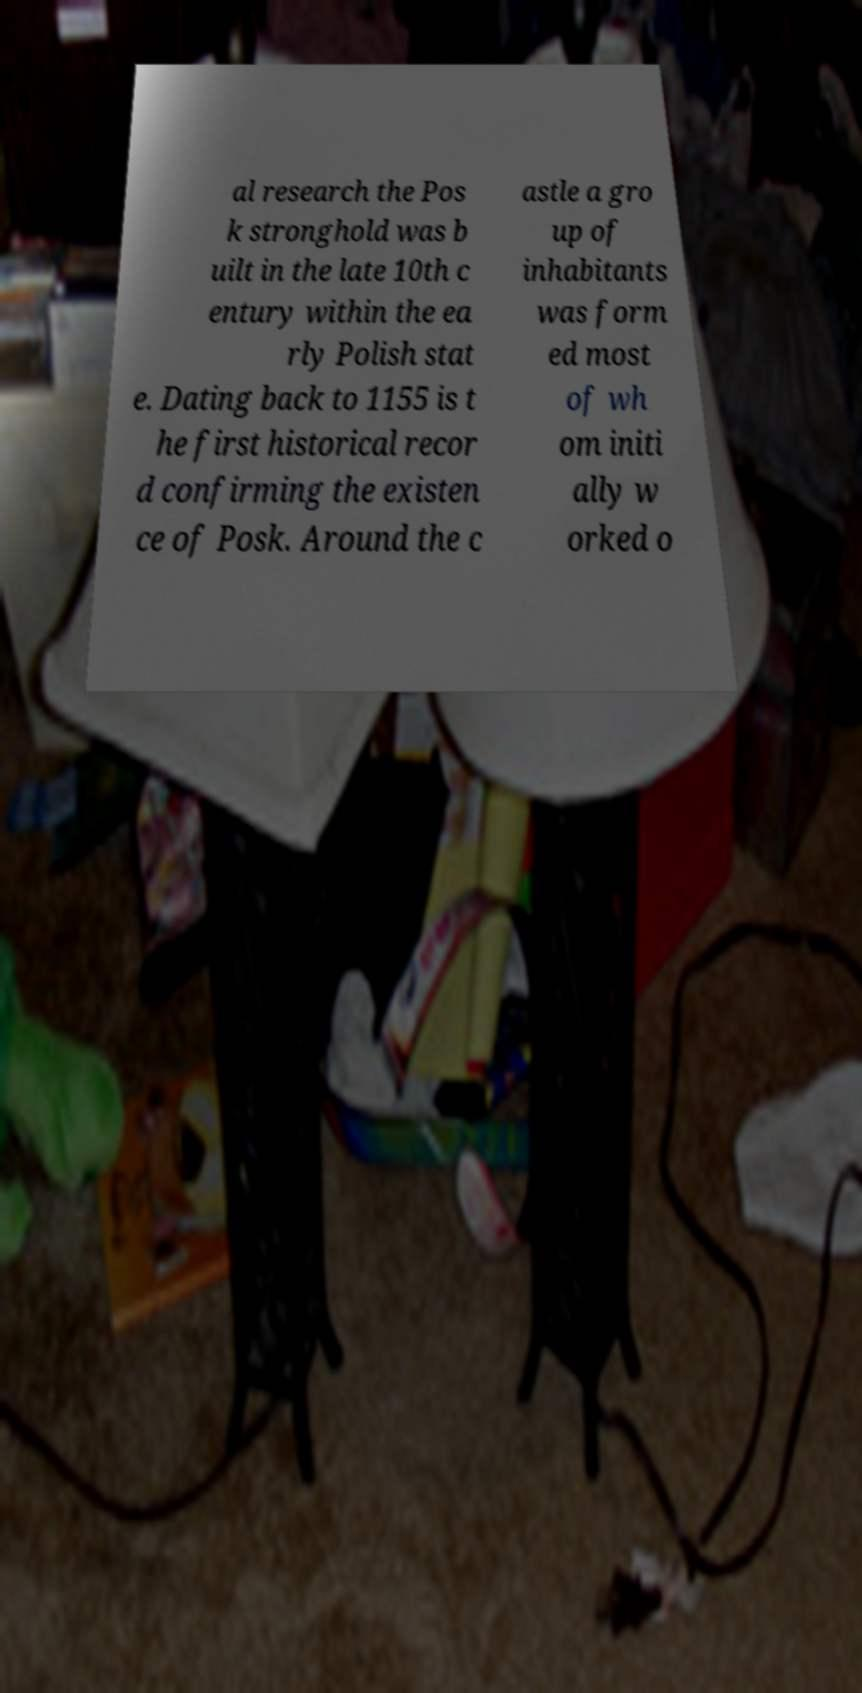I need the written content from this picture converted into text. Can you do that? al research the Pos k stronghold was b uilt in the late 10th c entury within the ea rly Polish stat e. Dating back to 1155 is t he first historical recor d confirming the existen ce of Posk. Around the c astle a gro up of inhabitants was form ed most of wh om initi ally w orked o 